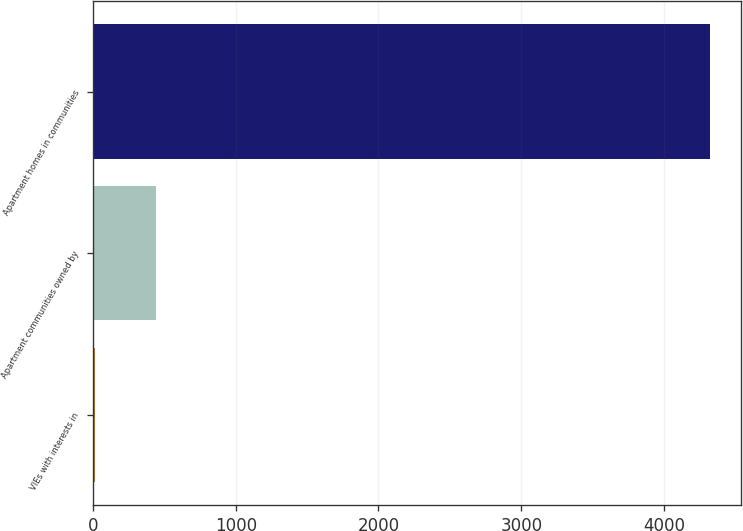Convert chart. <chart><loc_0><loc_0><loc_500><loc_500><bar_chart><fcel>VIEs with interests in<fcel>Apartment communities owned by<fcel>Apartment homes in communities<nl><fcel>14<fcel>444.7<fcel>4321<nl></chart> 